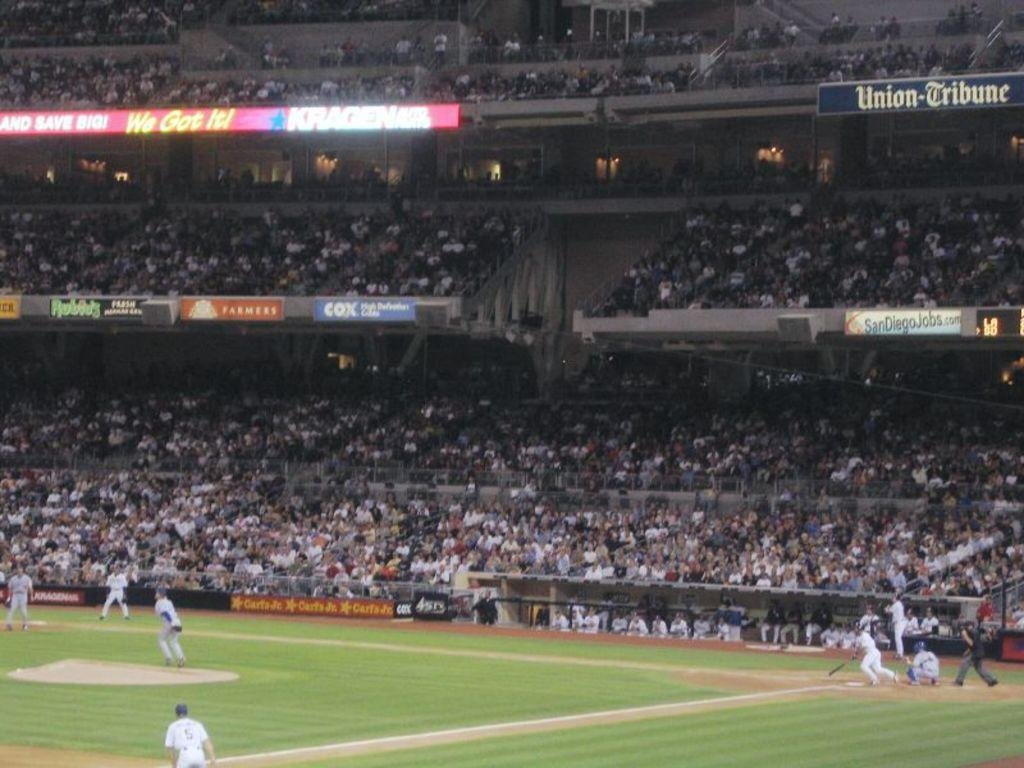<image>
Present a compact description of the photo's key features. Baseball game with different sponsors on the billboard, called Union-Tribune. 